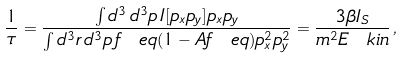Convert formula to latex. <formula><loc_0><loc_0><loc_500><loc_500>\frac { 1 } { \tau } = \frac { \int d ^ { 3 } \, d ^ { 3 } p \, I [ p _ { x } p _ { y } ] p _ { x } p _ { y } } { \int d ^ { 3 } r \, d ^ { 3 } p \, f _ { \ } e q ( 1 - A f _ { \ } e q ) p _ { x } ^ { 2 } p _ { y } ^ { 2 } } = \frac { 3 \beta I _ { S } } { m ^ { 2 } E _ { \ } k i n } \, ,</formula> 